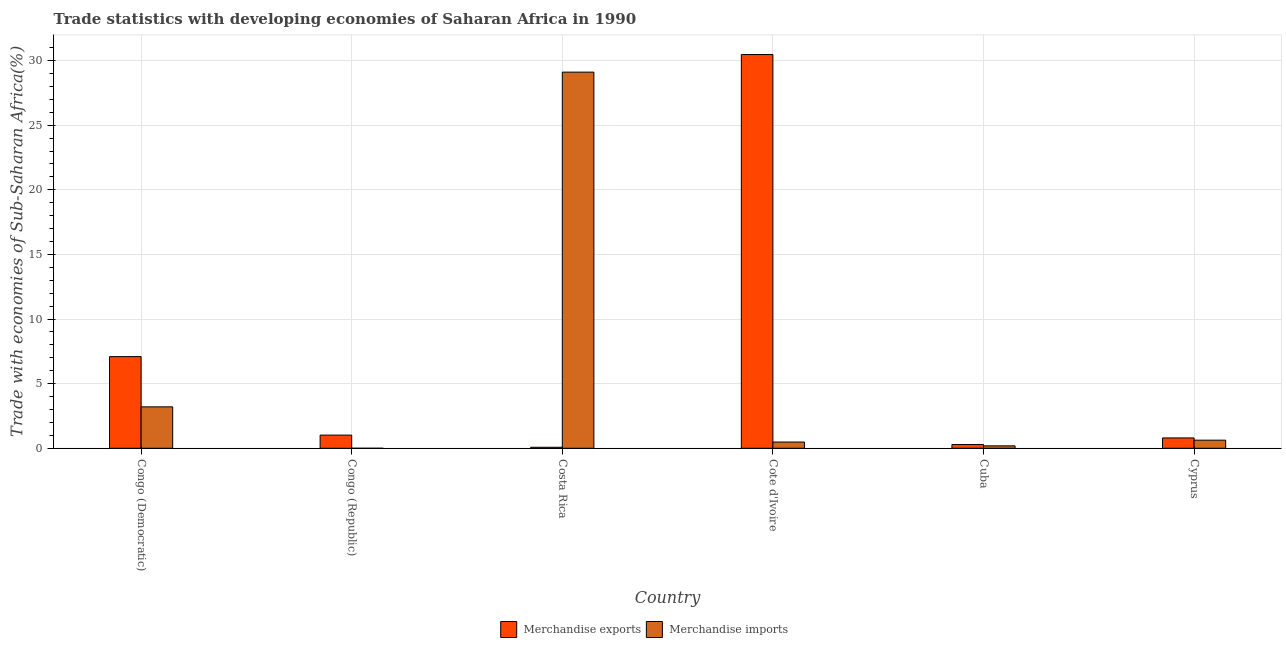How many different coloured bars are there?
Offer a very short reply. 2. How many bars are there on the 2nd tick from the left?
Your answer should be very brief. 2. What is the label of the 6th group of bars from the left?
Provide a succinct answer. Cyprus. What is the merchandise imports in Cote d'Ivoire?
Offer a very short reply. 0.48. Across all countries, what is the maximum merchandise imports?
Provide a short and direct response. 29.1. Across all countries, what is the minimum merchandise imports?
Provide a succinct answer. 0. In which country was the merchandise exports maximum?
Provide a short and direct response. Cote d'Ivoire. In which country was the merchandise exports minimum?
Your answer should be very brief. Costa Rica. What is the total merchandise exports in the graph?
Your answer should be very brief. 39.74. What is the difference between the merchandise imports in Congo (Republic) and that in Cote d'Ivoire?
Make the answer very short. -0.48. What is the difference between the merchandise exports in Congo (Republic) and the merchandise imports in Cuba?
Provide a succinct answer. 0.83. What is the average merchandise exports per country?
Provide a short and direct response. 6.62. What is the difference between the merchandise imports and merchandise exports in Congo (Republic)?
Your answer should be very brief. -1.02. In how many countries, is the merchandise exports greater than 29 %?
Your response must be concise. 1. What is the ratio of the merchandise exports in Cote d'Ivoire to that in Cuba?
Your answer should be compact. 104.59. What is the difference between the highest and the second highest merchandise exports?
Offer a terse response. 23.37. What is the difference between the highest and the lowest merchandise exports?
Keep it short and to the point. 30.38. In how many countries, is the merchandise imports greater than the average merchandise imports taken over all countries?
Offer a very short reply. 1. What does the 2nd bar from the left in Cote d'Ivoire represents?
Provide a succinct answer. Merchandise imports. How many countries are there in the graph?
Your answer should be compact. 6. Are the values on the major ticks of Y-axis written in scientific E-notation?
Make the answer very short. No. Does the graph contain grids?
Offer a terse response. Yes. How many legend labels are there?
Your answer should be very brief. 2. How are the legend labels stacked?
Your answer should be compact. Horizontal. What is the title of the graph?
Make the answer very short. Trade statistics with developing economies of Saharan Africa in 1990. What is the label or title of the Y-axis?
Make the answer very short. Trade with economies of Sub-Saharan Africa(%). What is the Trade with economies of Sub-Saharan Africa(%) in Merchandise exports in Congo (Democratic)?
Keep it short and to the point. 7.09. What is the Trade with economies of Sub-Saharan Africa(%) of Merchandise imports in Congo (Democratic)?
Make the answer very short. 3.2. What is the Trade with economies of Sub-Saharan Africa(%) of Merchandise exports in Congo (Republic)?
Provide a succinct answer. 1.02. What is the Trade with economies of Sub-Saharan Africa(%) in Merchandise imports in Congo (Republic)?
Give a very brief answer. 0. What is the Trade with economies of Sub-Saharan Africa(%) in Merchandise exports in Costa Rica?
Your response must be concise. 0.08. What is the Trade with economies of Sub-Saharan Africa(%) of Merchandise imports in Costa Rica?
Keep it short and to the point. 29.1. What is the Trade with economies of Sub-Saharan Africa(%) in Merchandise exports in Cote d'Ivoire?
Offer a very short reply. 30.46. What is the Trade with economies of Sub-Saharan Africa(%) of Merchandise imports in Cote d'Ivoire?
Provide a succinct answer. 0.48. What is the Trade with economies of Sub-Saharan Africa(%) in Merchandise exports in Cuba?
Keep it short and to the point. 0.29. What is the Trade with economies of Sub-Saharan Africa(%) in Merchandise imports in Cuba?
Provide a succinct answer. 0.19. What is the Trade with economies of Sub-Saharan Africa(%) of Merchandise exports in Cyprus?
Provide a short and direct response. 0.8. What is the Trade with economies of Sub-Saharan Africa(%) of Merchandise imports in Cyprus?
Give a very brief answer. 0.63. Across all countries, what is the maximum Trade with economies of Sub-Saharan Africa(%) of Merchandise exports?
Keep it short and to the point. 30.46. Across all countries, what is the maximum Trade with economies of Sub-Saharan Africa(%) in Merchandise imports?
Your answer should be very brief. 29.1. Across all countries, what is the minimum Trade with economies of Sub-Saharan Africa(%) in Merchandise exports?
Ensure brevity in your answer.  0.08. Across all countries, what is the minimum Trade with economies of Sub-Saharan Africa(%) of Merchandise imports?
Ensure brevity in your answer.  0. What is the total Trade with economies of Sub-Saharan Africa(%) in Merchandise exports in the graph?
Provide a short and direct response. 39.74. What is the total Trade with economies of Sub-Saharan Africa(%) of Merchandise imports in the graph?
Provide a short and direct response. 33.61. What is the difference between the Trade with economies of Sub-Saharan Africa(%) in Merchandise exports in Congo (Democratic) and that in Congo (Republic)?
Make the answer very short. 6.07. What is the difference between the Trade with economies of Sub-Saharan Africa(%) of Merchandise imports in Congo (Democratic) and that in Congo (Republic)?
Provide a succinct answer. 3.2. What is the difference between the Trade with economies of Sub-Saharan Africa(%) of Merchandise exports in Congo (Democratic) and that in Costa Rica?
Offer a terse response. 7.01. What is the difference between the Trade with economies of Sub-Saharan Africa(%) of Merchandise imports in Congo (Democratic) and that in Costa Rica?
Your response must be concise. -25.9. What is the difference between the Trade with economies of Sub-Saharan Africa(%) of Merchandise exports in Congo (Democratic) and that in Cote d'Ivoire?
Provide a succinct answer. -23.37. What is the difference between the Trade with economies of Sub-Saharan Africa(%) in Merchandise imports in Congo (Democratic) and that in Cote d'Ivoire?
Your answer should be very brief. 2.72. What is the difference between the Trade with economies of Sub-Saharan Africa(%) in Merchandise exports in Congo (Democratic) and that in Cuba?
Ensure brevity in your answer.  6.8. What is the difference between the Trade with economies of Sub-Saharan Africa(%) of Merchandise imports in Congo (Democratic) and that in Cuba?
Keep it short and to the point. 3.02. What is the difference between the Trade with economies of Sub-Saharan Africa(%) of Merchandise exports in Congo (Democratic) and that in Cyprus?
Provide a succinct answer. 6.29. What is the difference between the Trade with economies of Sub-Saharan Africa(%) of Merchandise imports in Congo (Democratic) and that in Cyprus?
Provide a short and direct response. 2.58. What is the difference between the Trade with economies of Sub-Saharan Africa(%) of Merchandise exports in Congo (Republic) and that in Costa Rica?
Offer a very short reply. 0.94. What is the difference between the Trade with economies of Sub-Saharan Africa(%) in Merchandise imports in Congo (Republic) and that in Costa Rica?
Give a very brief answer. -29.1. What is the difference between the Trade with economies of Sub-Saharan Africa(%) in Merchandise exports in Congo (Republic) and that in Cote d'Ivoire?
Offer a very short reply. -29.44. What is the difference between the Trade with economies of Sub-Saharan Africa(%) in Merchandise imports in Congo (Republic) and that in Cote d'Ivoire?
Ensure brevity in your answer.  -0.48. What is the difference between the Trade with economies of Sub-Saharan Africa(%) in Merchandise exports in Congo (Republic) and that in Cuba?
Your response must be concise. 0.73. What is the difference between the Trade with economies of Sub-Saharan Africa(%) of Merchandise imports in Congo (Republic) and that in Cuba?
Your answer should be compact. -0.19. What is the difference between the Trade with economies of Sub-Saharan Africa(%) of Merchandise exports in Congo (Republic) and that in Cyprus?
Your answer should be very brief. 0.22. What is the difference between the Trade with economies of Sub-Saharan Africa(%) in Merchandise imports in Congo (Republic) and that in Cyprus?
Give a very brief answer. -0.63. What is the difference between the Trade with economies of Sub-Saharan Africa(%) of Merchandise exports in Costa Rica and that in Cote d'Ivoire?
Your answer should be very brief. -30.38. What is the difference between the Trade with economies of Sub-Saharan Africa(%) of Merchandise imports in Costa Rica and that in Cote d'Ivoire?
Give a very brief answer. 28.62. What is the difference between the Trade with economies of Sub-Saharan Africa(%) in Merchandise exports in Costa Rica and that in Cuba?
Offer a terse response. -0.21. What is the difference between the Trade with economies of Sub-Saharan Africa(%) in Merchandise imports in Costa Rica and that in Cuba?
Ensure brevity in your answer.  28.91. What is the difference between the Trade with economies of Sub-Saharan Africa(%) in Merchandise exports in Costa Rica and that in Cyprus?
Give a very brief answer. -0.72. What is the difference between the Trade with economies of Sub-Saharan Africa(%) in Merchandise imports in Costa Rica and that in Cyprus?
Ensure brevity in your answer.  28.47. What is the difference between the Trade with economies of Sub-Saharan Africa(%) of Merchandise exports in Cote d'Ivoire and that in Cuba?
Your answer should be compact. 30.17. What is the difference between the Trade with economies of Sub-Saharan Africa(%) of Merchandise imports in Cote d'Ivoire and that in Cuba?
Provide a succinct answer. 0.3. What is the difference between the Trade with economies of Sub-Saharan Africa(%) in Merchandise exports in Cote d'Ivoire and that in Cyprus?
Give a very brief answer. 29.66. What is the difference between the Trade with economies of Sub-Saharan Africa(%) of Merchandise imports in Cote d'Ivoire and that in Cyprus?
Keep it short and to the point. -0.14. What is the difference between the Trade with economies of Sub-Saharan Africa(%) of Merchandise exports in Cuba and that in Cyprus?
Ensure brevity in your answer.  -0.51. What is the difference between the Trade with economies of Sub-Saharan Africa(%) in Merchandise imports in Cuba and that in Cyprus?
Provide a succinct answer. -0.44. What is the difference between the Trade with economies of Sub-Saharan Africa(%) of Merchandise exports in Congo (Democratic) and the Trade with economies of Sub-Saharan Africa(%) of Merchandise imports in Congo (Republic)?
Make the answer very short. 7.09. What is the difference between the Trade with economies of Sub-Saharan Africa(%) in Merchandise exports in Congo (Democratic) and the Trade with economies of Sub-Saharan Africa(%) in Merchandise imports in Costa Rica?
Your response must be concise. -22.01. What is the difference between the Trade with economies of Sub-Saharan Africa(%) of Merchandise exports in Congo (Democratic) and the Trade with economies of Sub-Saharan Africa(%) of Merchandise imports in Cote d'Ivoire?
Your answer should be compact. 6.61. What is the difference between the Trade with economies of Sub-Saharan Africa(%) of Merchandise exports in Congo (Democratic) and the Trade with economies of Sub-Saharan Africa(%) of Merchandise imports in Cuba?
Give a very brief answer. 6.9. What is the difference between the Trade with economies of Sub-Saharan Africa(%) of Merchandise exports in Congo (Democratic) and the Trade with economies of Sub-Saharan Africa(%) of Merchandise imports in Cyprus?
Your response must be concise. 6.46. What is the difference between the Trade with economies of Sub-Saharan Africa(%) of Merchandise exports in Congo (Republic) and the Trade with economies of Sub-Saharan Africa(%) of Merchandise imports in Costa Rica?
Offer a terse response. -28.08. What is the difference between the Trade with economies of Sub-Saharan Africa(%) in Merchandise exports in Congo (Republic) and the Trade with economies of Sub-Saharan Africa(%) in Merchandise imports in Cote d'Ivoire?
Offer a terse response. 0.54. What is the difference between the Trade with economies of Sub-Saharan Africa(%) of Merchandise exports in Congo (Republic) and the Trade with economies of Sub-Saharan Africa(%) of Merchandise imports in Cuba?
Your answer should be compact. 0.83. What is the difference between the Trade with economies of Sub-Saharan Africa(%) of Merchandise exports in Congo (Republic) and the Trade with economies of Sub-Saharan Africa(%) of Merchandise imports in Cyprus?
Keep it short and to the point. 0.39. What is the difference between the Trade with economies of Sub-Saharan Africa(%) in Merchandise exports in Costa Rica and the Trade with economies of Sub-Saharan Africa(%) in Merchandise imports in Cote d'Ivoire?
Keep it short and to the point. -0.41. What is the difference between the Trade with economies of Sub-Saharan Africa(%) in Merchandise exports in Costa Rica and the Trade with economies of Sub-Saharan Africa(%) in Merchandise imports in Cuba?
Provide a succinct answer. -0.11. What is the difference between the Trade with economies of Sub-Saharan Africa(%) of Merchandise exports in Costa Rica and the Trade with economies of Sub-Saharan Africa(%) of Merchandise imports in Cyprus?
Your answer should be compact. -0.55. What is the difference between the Trade with economies of Sub-Saharan Africa(%) of Merchandise exports in Cote d'Ivoire and the Trade with economies of Sub-Saharan Africa(%) of Merchandise imports in Cuba?
Provide a succinct answer. 30.27. What is the difference between the Trade with economies of Sub-Saharan Africa(%) of Merchandise exports in Cote d'Ivoire and the Trade with economies of Sub-Saharan Africa(%) of Merchandise imports in Cyprus?
Give a very brief answer. 29.83. What is the difference between the Trade with economies of Sub-Saharan Africa(%) in Merchandise exports in Cuba and the Trade with economies of Sub-Saharan Africa(%) in Merchandise imports in Cyprus?
Your answer should be very brief. -0.34. What is the average Trade with economies of Sub-Saharan Africa(%) in Merchandise exports per country?
Give a very brief answer. 6.62. What is the average Trade with economies of Sub-Saharan Africa(%) of Merchandise imports per country?
Your answer should be compact. 5.6. What is the difference between the Trade with economies of Sub-Saharan Africa(%) of Merchandise exports and Trade with economies of Sub-Saharan Africa(%) of Merchandise imports in Congo (Democratic)?
Offer a terse response. 3.89. What is the difference between the Trade with economies of Sub-Saharan Africa(%) in Merchandise exports and Trade with economies of Sub-Saharan Africa(%) in Merchandise imports in Congo (Republic)?
Your answer should be compact. 1.02. What is the difference between the Trade with economies of Sub-Saharan Africa(%) in Merchandise exports and Trade with economies of Sub-Saharan Africa(%) in Merchandise imports in Costa Rica?
Offer a terse response. -29.02. What is the difference between the Trade with economies of Sub-Saharan Africa(%) in Merchandise exports and Trade with economies of Sub-Saharan Africa(%) in Merchandise imports in Cote d'Ivoire?
Offer a terse response. 29.98. What is the difference between the Trade with economies of Sub-Saharan Africa(%) of Merchandise exports and Trade with economies of Sub-Saharan Africa(%) of Merchandise imports in Cuba?
Provide a short and direct response. 0.1. What is the difference between the Trade with economies of Sub-Saharan Africa(%) of Merchandise exports and Trade with economies of Sub-Saharan Africa(%) of Merchandise imports in Cyprus?
Offer a terse response. 0.17. What is the ratio of the Trade with economies of Sub-Saharan Africa(%) of Merchandise exports in Congo (Democratic) to that in Congo (Republic)?
Provide a short and direct response. 6.96. What is the ratio of the Trade with economies of Sub-Saharan Africa(%) in Merchandise imports in Congo (Democratic) to that in Congo (Republic)?
Make the answer very short. 3106.91. What is the ratio of the Trade with economies of Sub-Saharan Africa(%) of Merchandise exports in Congo (Democratic) to that in Costa Rica?
Provide a short and direct response. 91.14. What is the ratio of the Trade with economies of Sub-Saharan Africa(%) in Merchandise imports in Congo (Democratic) to that in Costa Rica?
Give a very brief answer. 0.11. What is the ratio of the Trade with economies of Sub-Saharan Africa(%) of Merchandise exports in Congo (Democratic) to that in Cote d'Ivoire?
Make the answer very short. 0.23. What is the ratio of the Trade with economies of Sub-Saharan Africa(%) of Merchandise imports in Congo (Democratic) to that in Cote d'Ivoire?
Your answer should be compact. 6.63. What is the ratio of the Trade with economies of Sub-Saharan Africa(%) in Merchandise exports in Congo (Democratic) to that in Cuba?
Offer a very short reply. 24.35. What is the ratio of the Trade with economies of Sub-Saharan Africa(%) in Merchandise imports in Congo (Democratic) to that in Cuba?
Give a very brief answer. 17.02. What is the ratio of the Trade with economies of Sub-Saharan Africa(%) of Merchandise exports in Congo (Democratic) to that in Cyprus?
Your response must be concise. 8.85. What is the ratio of the Trade with economies of Sub-Saharan Africa(%) in Merchandise imports in Congo (Democratic) to that in Cyprus?
Offer a terse response. 5.1. What is the ratio of the Trade with economies of Sub-Saharan Africa(%) in Merchandise exports in Congo (Republic) to that in Costa Rica?
Keep it short and to the point. 13.1. What is the ratio of the Trade with economies of Sub-Saharan Africa(%) of Merchandise imports in Congo (Republic) to that in Costa Rica?
Make the answer very short. 0. What is the ratio of the Trade with economies of Sub-Saharan Africa(%) in Merchandise exports in Congo (Republic) to that in Cote d'Ivoire?
Make the answer very short. 0.03. What is the ratio of the Trade with economies of Sub-Saharan Africa(%) of Merchandise imports in Congo (Republic) to that in Cote d'Ivoire?
Your answer should be very brief. 0. What is the ratio of the Trade with economies of Sub-Saharan Africa(%) of Merchandise exports in Congo (Republic) to that in Cuba?
Offer a terse response. 3.5. What is the ratio of the Trade with economies of Sub-Saharan Africa(%) of Merchandise imports in Congo (Republic) to that in Cuba?
Offer a very short reply. 0.01. What is the ratio of the Trade with economies of Sub-Saharan Africa(%) in Merchandise exports in Congo (Republic) to that in Cyprus?
Offer a terse response. 1.27. What is the ratio of the Trade with economies of Sub-Saharan Africa(%) of Merchandise imports in Congo (Republic) to that in Cyprus?
Offer a terse response. 0. What is the ratio of the Trade with economies of Sub-Saharan Africa(%) of Merchandise exports in Costa Rica to that in Cote d'Ivoire?
Make the answer very short. 0. What is the ratio of the Trade with economies of Sub-Saharan Africa(%) in Merchandise imports in Costa Rica to that in Cote d'Ivoire?
Provide a succinct answer. 60.2. What is the ratio of the Trade with economies of Sub-Saharan Africa(%) of Merchandise exports in Costa Rica to that in Cuba?
Offer a terse response. 0.27. What is the ratio of the Trade with economies of Sub-Saharan Africa(%) in Merchandise imports in Costa Rica to that in Cuba?
Provide a succinct answer. 154.59. What is the ratio of the Trade with economies of Sub-Saharan Africa(%) in Merchandise exports in Costa Rica to that in Cyprus?
Ensure brevity in your answer.  0.1. What is the ratio of the Trade with economies of Sub-Saharan Africa(%) in Merchandise imports in Costa Rica to that in Cyprus?
Provide a succinct answer. 46.32. What is the ratio of the Trade with economies of Sub-Saharan Africa(%) in Merchandise exports in Cote d'Ivoire to that in Cuba?
Your answer should be very brief. 104.59. What is the ratio of the Trade with economies of Sub-Saharan Africa(%) in Merchandise imports in Cote d'Ivoire to that in Cuba?
Your answer should be compact. 2.57. What is the ratio of the Trade with economies of Sub-Saharan Africa(%) in Merchandise exports in Cote d'Ivoire to that in Cyprus?
Provide a short and direct response. 38.02. What is the ratio of the Trade with economies of Sub-Saharan Africa(%) of Merchandise imports in Cote d'Ivoire to that in Cyprus?
Keep it short and to the point. 0.77. What is the ratio of the Trade with economies of Sub-Saharan Africa(%) in Merchandise exports in Cuba to that in Cyprus?
Offer a very short reply. 0.36. What is the ratio of the Trade with economies of Sub-Saharan Africa(%) of Merchandise imports in Cuba to that in Cyprus?
Offer a terse response. 0.3. What is the difference between the highest and the second highest Trade with economies of Sub-Saharan Africa(%) of Merchandise exports?
Offer a terse response. 23.37. What is the difference between the highest and the second highest Trade with economies of Sub-Saharan Africa(%) in Merchandise imports?
Provide a short and direct response. 25.9. What is the difference between the highest and the lowest Trade with economies of Sub-Saharan Africa(%) of Merchandise exports?
Your answer should be compact. 30.38. What is the difference between the highest and the lowest Trade with economies of Sub-Saharan Africa(%) of Merchandise imports?
Make the answer very short. 29.1. 